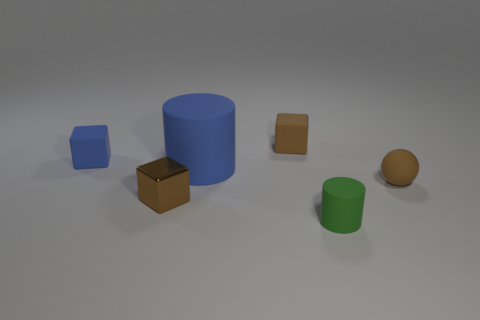What is the overall mood or atmosphere you could infer from this image? The image conveys a minimalist and orderly atmosphere, featuring geometric shapes with a soft shadowing, all against a neutral background, suggesting an environment designed for focus and simplicity. 